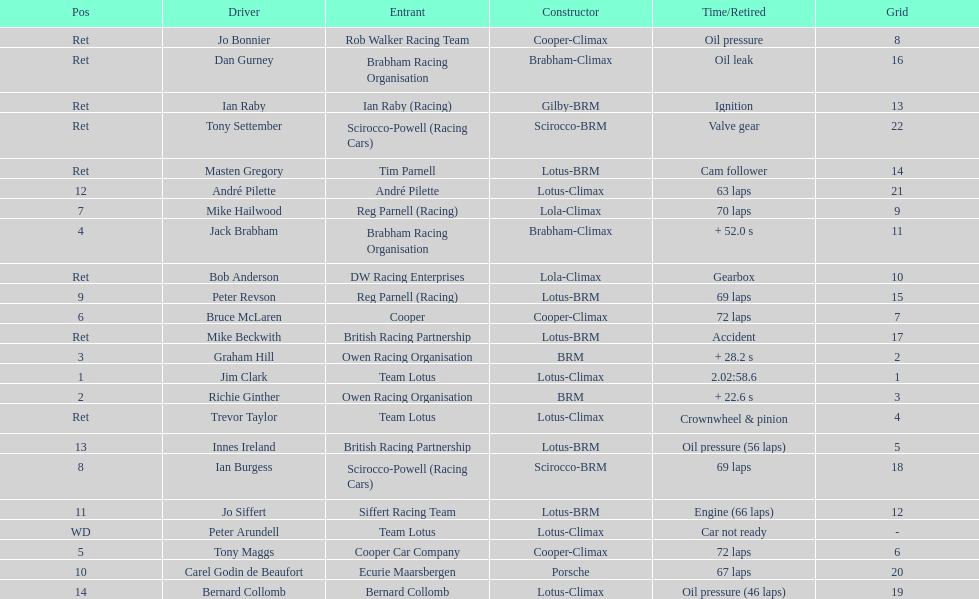Who was the top finisher that drove a cooper-climax? Tony Maggs. Would you be able to parse every entry in this table? {'header': ['Pos', 'Driver', 'Entrant', 'Constructor', 'Time/Retired', 'Grid'], 'rows': [['Ret', 'Jo Bonnier', 'Rob Walker Racing Team', 'Cooper-Climax', 'Oil pressure', '8'], ['Ret', 'Dan Gurney', 'Brabham Racing Organisation', 'Brabham-Climax', 'Oil leak', '16'], ['Ret', 'Ian Raby', 'Ian Raby (Racing)', 'Gilby-BRM', 'Ignition', '13'], ['Ret', 'Tony Settember', 'Scirocco-Powell (Racing Cars)', 'Scirocco-BRM', 'Valve gear', '22'], ['Ret', 'Masten Gregory', 'Tim Parnell', 'Lotus-BRM', 'Cam follower', '14'], ['12', 'André Pilette', 'André Pilette', 'Lotus-Climax', '63 laps', '21'], ['7', 'Mike Hailwood', 'Reg Parnell (Racing)', 'Lola-Climax', '70 laps', '9'], ['4', 'Jack Brabham', 'Brabham Racing Organisation', 'Brabham-Climax', '+ 52.0 s', '11'], ['Ret', 'Bob Anderson', 'DW Racing Enterprises', 'Lola-Climax', 'Gearbox', '10'], ['9', 'Peter Revson', 'Reg Parnell (Racing)', 'Lotus-BRM', '69 laps', '15'], ['6', 'Bruce McLaren', 'Cooper', 'Cooper-Climax', '72 laps', '7'], ['Ret', 'Mike Beckwith', 'British Racing Partnership', 'Lotus-BRM', 'Accident', '17'], ['3', 'Graham Hill', 'Owen Racing Organisation', 'BRM', '+ 28.2 s', '2'], ['1', 'Jim Clark', 'Team Lotus', 'Lotus-Climax', '2.02:58.6', '1'], ['2', 'Richie Ginther', 'Owen Racing Organisation', 'BRM', '+ 22.6 s', '3'], ['Ret', 'Trevor Taylor', 'Team Lotus', 'Lotus-Climax', 'Crownwheel & pinion', '4'], ['13', 'Innes Ireland', 'British Racing Partnership', 'Lotus-BRM', 'Oil pressure (56 laps)', '5'], ['8', 'Ian Burgess', 'Scirocco-Powell (Racing Cars)', 'Scirocco-BRM', '69 laps', '18'], ['11', 'Jo Siffert', 'Siffert Racing Team', 'Lotus-BRM', 'Engine (66 laps)', '12'], ['WD', 'Peter Arundell', 'Team Lotus', 'Lotus-Climax', 'Car not ready', '-'], ['5', 'Tony Maggs', 'Cooper Car Company', 'Cooper-Climax', '72 laps', '6'], ['10', 'Carel Godin de Beaufort', 'Ecurie Maarsbergen', 'Porsche', '67 laps', '20'], ['14', 'Bernard Collomb', 'Bernard Collomb', 'Lotus-Climax', 'Oil pressure (46 laps)', '19']]} 